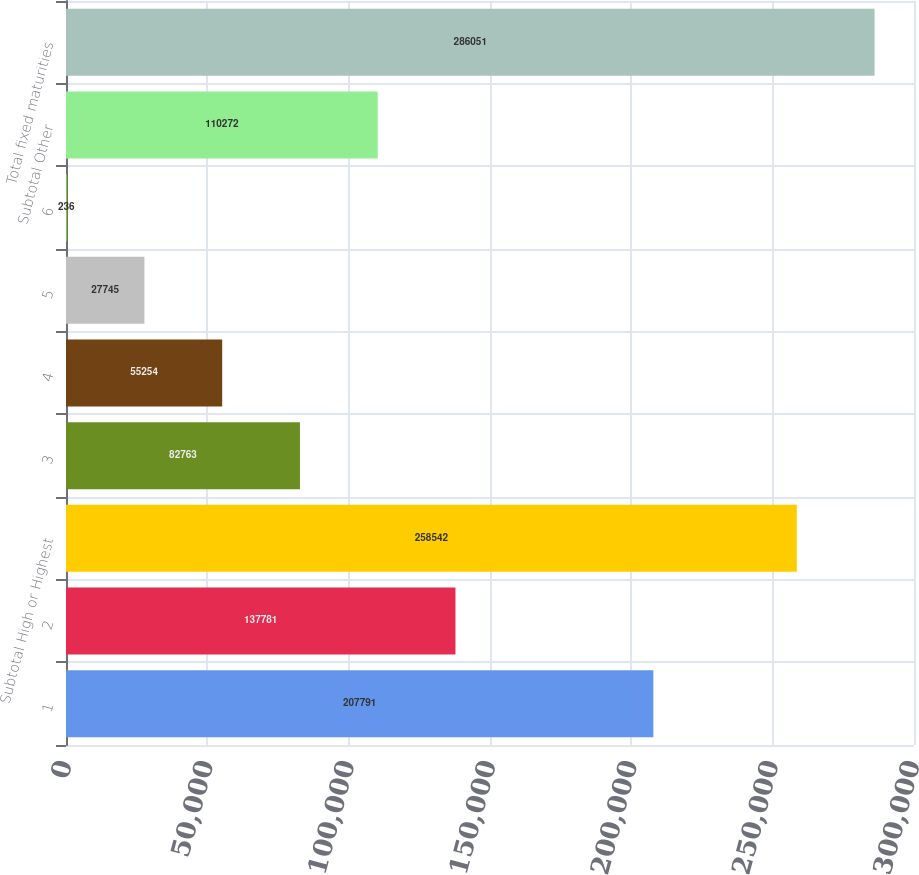Convert chart. <chart><loc_0><loc_0><loc_500><loc_500><bar_chart><fcel>1<fcel>2<fcel>Subtotal High or Highest<fcel>3<fcel>4<fcel>5<fcel>6<fcel>Subtotal Other<fcel>Total fixed maturities<nl><fcel>207791<fcel>137781<fcel>258542<fcel>82763<fcel>55254<fcel>27745<fcel>236<fcel>110272<fcel>286051<nl></chart> 